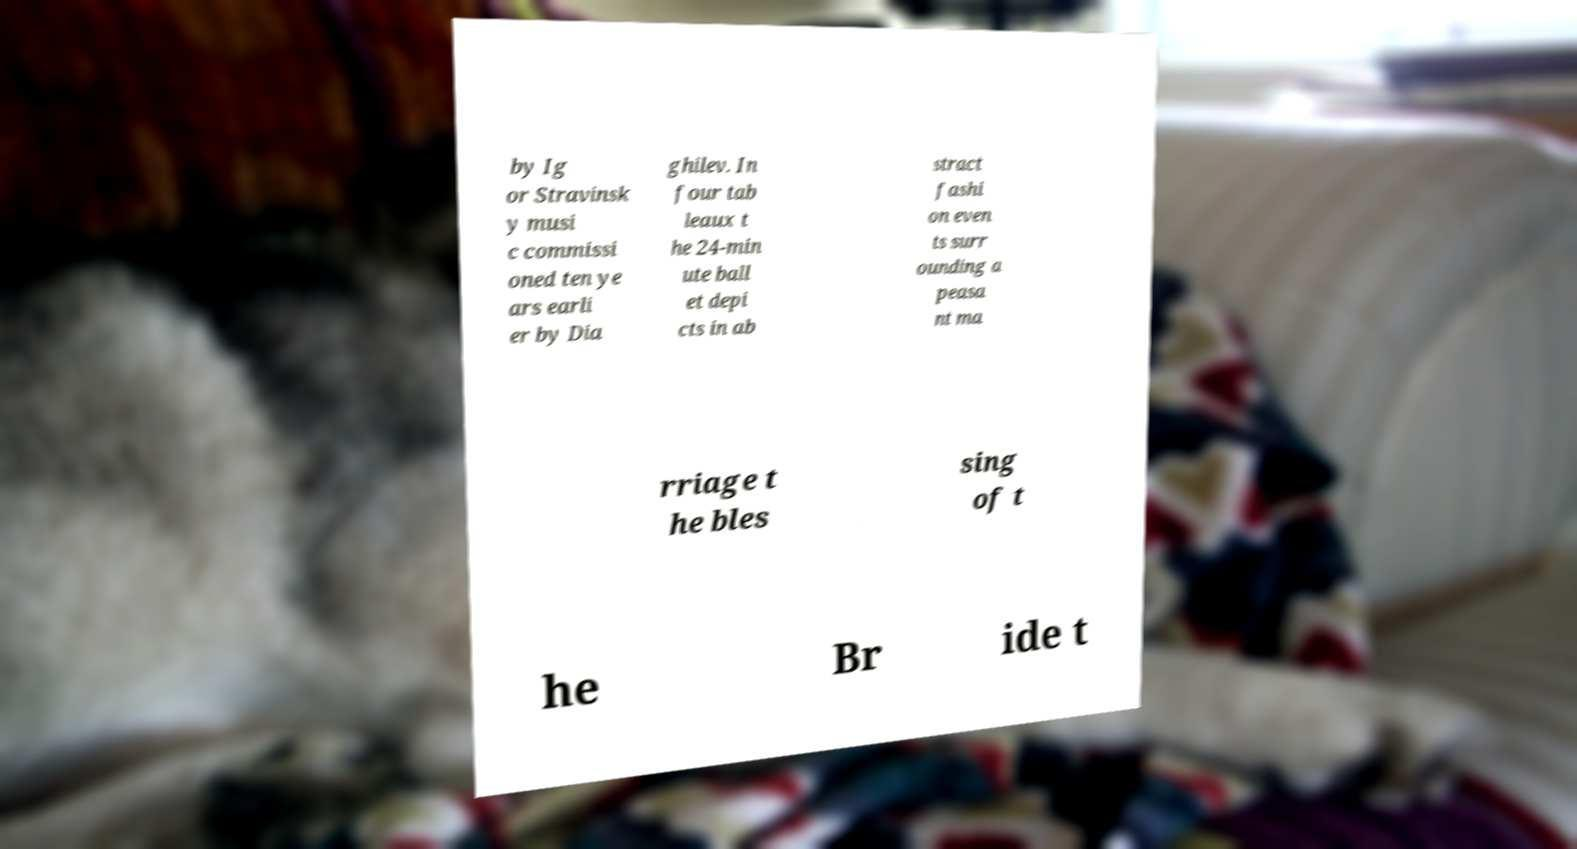I need the written content from this picture converted into text. Can you do that? by Ig or Stravinsk y musi c commissi oned ten ye ars earli er by Dia ghilev. In four tab leaux t he 24-min ute ball et depi cts in ab stract fashi on even ts surr ounding a peasa nt ma rriage t he bles sing of t he Br ide t 